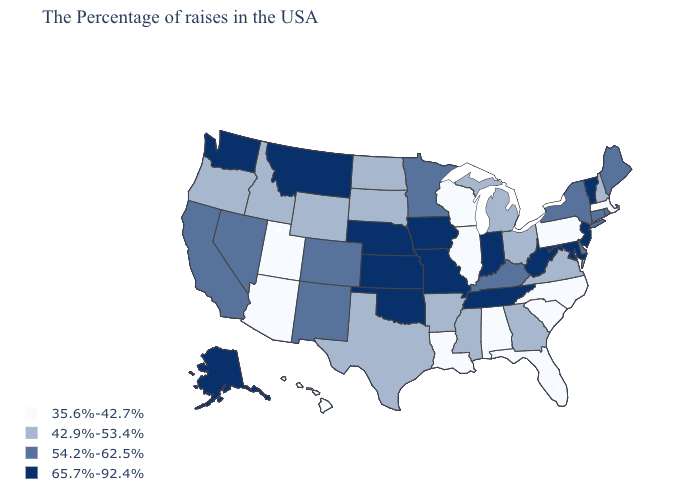What is the value of Kentucky?
Concise answer only. 54.2%-62.5%. How many symbols are there in the legend?
Quick response, please. 4. Among the states that border Kansas , does Oklahoma have the lowest value?
Write a very short answer. No. What is the value of New Hampshire?
Short answer required. 42.9%-53.4%. Which states have the lowest value in the USA?
Answer briefly. Massachusetts, Pennsylvania, North Carolina, South Carolina, Florida, Alabama, Wisconsin, Illinois, Louisiana, Utah, Arizona, Hawaii. What is the lowest value in the West?
Give a very brief answer. 35.6%-42.7%. What is the value of New Mexico?
Quick response, please. 54.2%-62.5%. Name the states that have a value in the range 42.9%-53.4%?
Answer briefly. New Hampshire, Virginia, Ohio, Georgia, Michigan, Mississippi, Arkansas, Texas, South Dakota, North Dakota, Wyoming, Idaho, Oregon. Does Montana have the lowest value in the USA?
Short answer required. No. Among the states that border South Carolina , which have the highest value?
Concise answer only. Georgia. Does Delaware have the same value as Texas?
Be succinct. No. Does Washington have the highest value in the West?
Give a very brief answer. Yes. Does Nevada have the highest value in the West?
Quick response, please. No. Does Utah have a lower value than Pennsylvania?
Give a very brief answer. No. Which states have the lowest value in the USA?
Quick response, please. Massachusetts, Pennsylvania, North Carolina, South Carolina, Florida, Alabama, Wisconsin, Illinois, Louisiana, Utah, Arizona, Hawaii. 